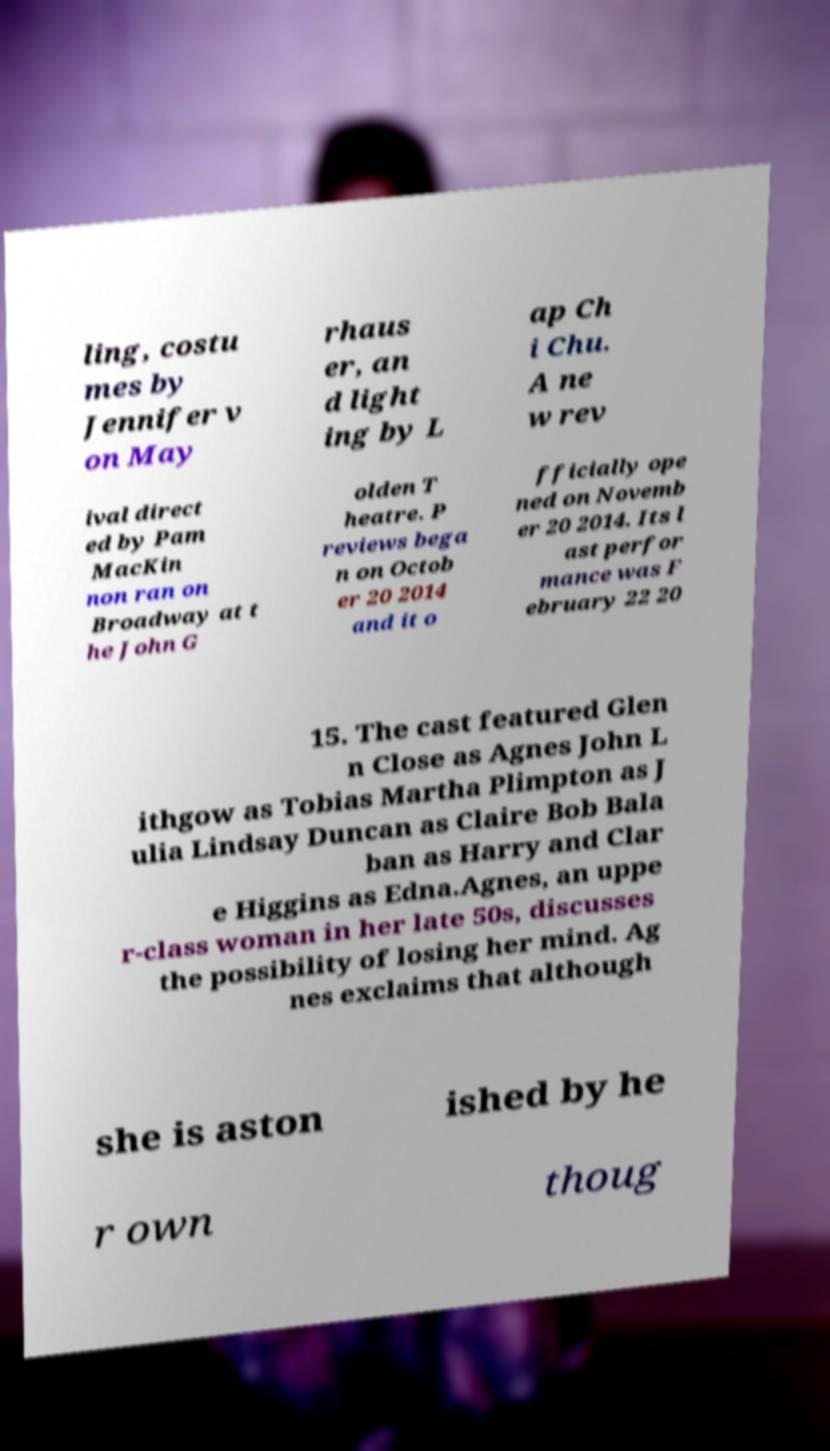There's text embedded in this image that I need extracted. Can you transcribe it verbatim? ling, costu mes by Jennifer v on May rhaus er, an d light ing by L ap Ch i Chu. A ne w rev ival direct ed by Pam MacKin non ran on Broadway at t he John G olden T heatre. P reviews bega n on Octob er 20 2014 and it o fficially ope ned on Novemb er 20 2014. Its l ast perfor mance was F ebruary 22 20 15. The cast featured Glen n Close as Agnes John L ithgow as Tobias Martha Plimpton as J ulia Lindsay Duncan as Claire Bob Bala ban as Harry and Clar e Higgins as Edna.Agnes, an uppe r-class woman in her late 50s, discusses the possibility of losing her mind. Ag nes exclaims that although she is aston ished by he r own thoug 